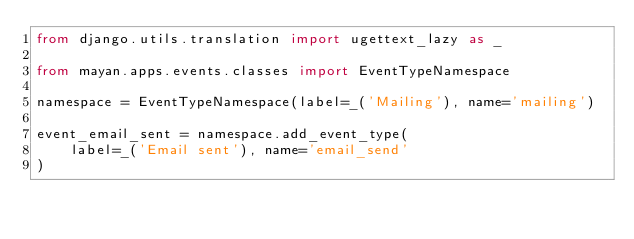<code> <loc_0><loc_0><loc_500><loc_500><_Python_>from django.utils.translation import ugettext_lazy as _

from mayan.apps.events.classes import EventTypeNamespace

namespace = EventTypeNamespace(label=_('Mailing'), name='mailing')

event_email_sent = namespace.add_event_type(
    label=_('Email sent'), name='email_send'
)
</code> 